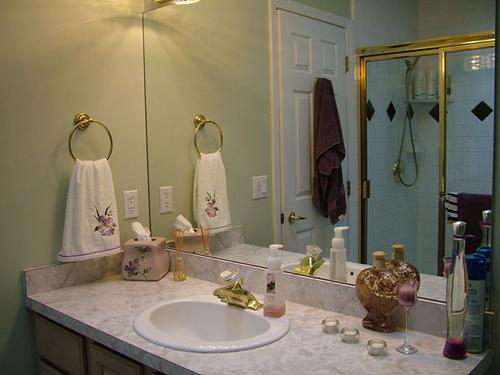Did a man or a woman decorate the bathroom?
Concise answer only. Woman. What color is the soap in the bottle?
Quick response, please. Pink. What is on the towel?
Write a very short answer. Flower. What is the design of the towel on the towel ring?
Be succinct. Flower. Is this in someone's home?
Write a very short answer. Yes. Is there a bathtub shown in the picture?
Be succinct. No. What sex of person primarily uses this sink?
Write a very short answer. Female. 